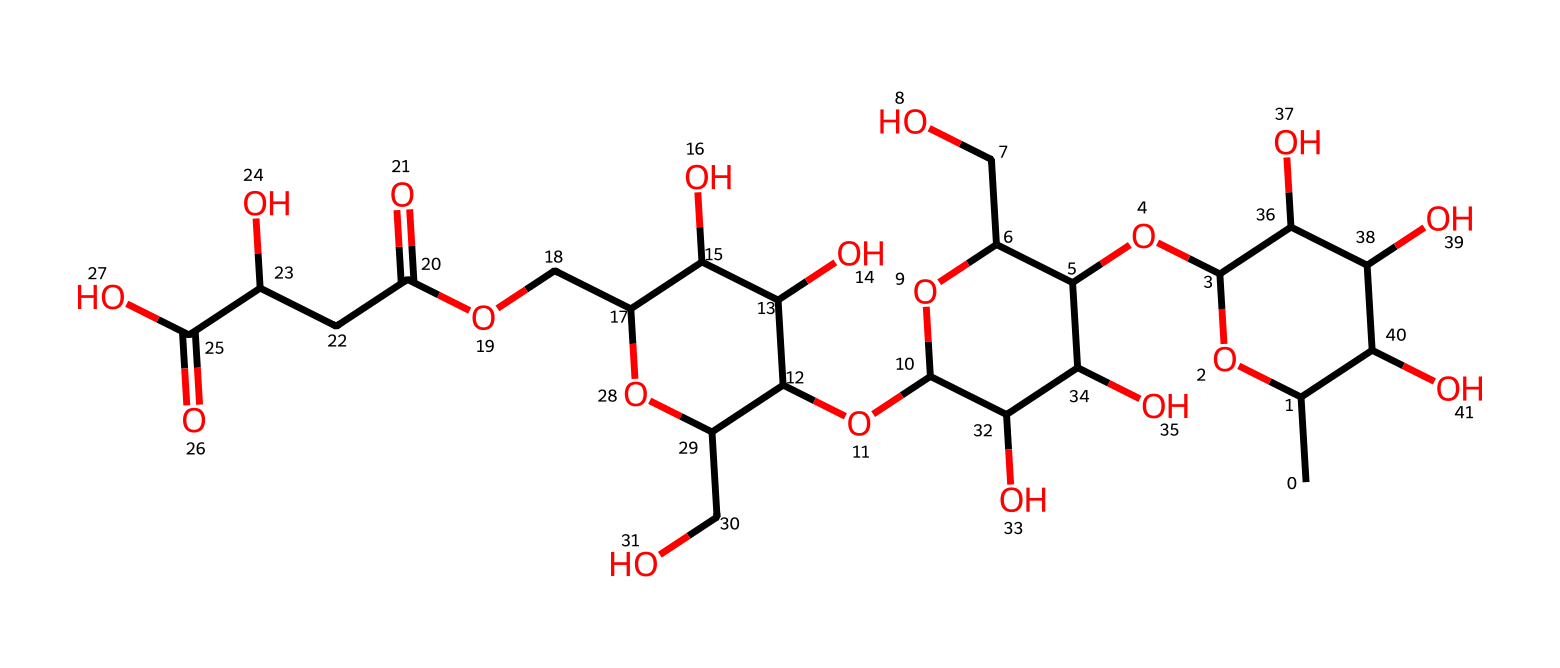What is the main structural component of xanthan gum? Xanthan gum is primarily comprised of polysaccharide chains, specifically a linear chain of (1→4)-linked β-D-glucose residues with side branches that contain various sugars. This relationship is evident from the repeating structural motifs in the provided SMILES notation.
Answer: polysaccharide How many oxygen atoms are present in the structure? By analyzing the SMILES representation, one can count the oxygen atoms present, which appear in the hydroxyl groups and ether linkages. The total count yields 12 oxygen atoms.
Answer: 12 What type of chemical bond predominantly links the sugar units in xanthan gum? Xanthan gum features glycosidic linkages for the connection between sugar units, specifically β-(1→4) bonds. This detail can be inferred from the repeated references to sugar groups in the SMILES.
Answer: glycosidic Which part of the structure contributes to xanthan gum's viscosity? The extensive polysaccharide backbone along with the ability to form hydrogen bonds contributes significantly to viscous properties. This can be deduced from observing the numerous hydroxyl groups (−OH) in the structure that promote strong intermolecular forces.
Answer: polysaccharide backbone What non-Newtonian behavior does xanthan gum primarily exhibit? Xanthan gum exhibits shear-thinning behavior, which is typical of many non-Newtonian fluids where viscosity decreases under shear stress. This characteristic can be derived from its molecular structure and the interactions among its polymer chains under mechanical forces.
Answer: shear-thinning 